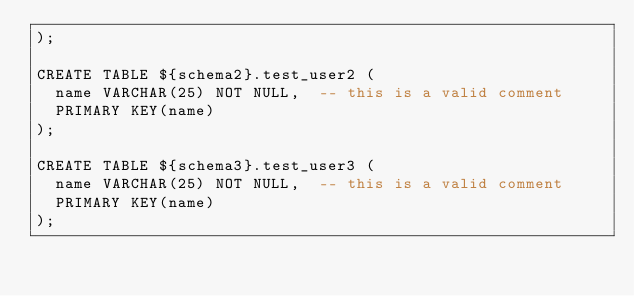<code> <loc_0><loc_0><loc_500><loc_500><_SQL_>);

CREATE TABLE ${schema2}.test_user2 (
  name VARCHAR(25) NOT NULL,  -- this is a valid comment
  PRIMARY KEY(name)
);

CREATE TABLE ${schema3}.test_user3 (
  name VARCHAR(25) NOT NULL,  -- this is a valid comment
  PRIMARY KEY(name)
);
</code> 